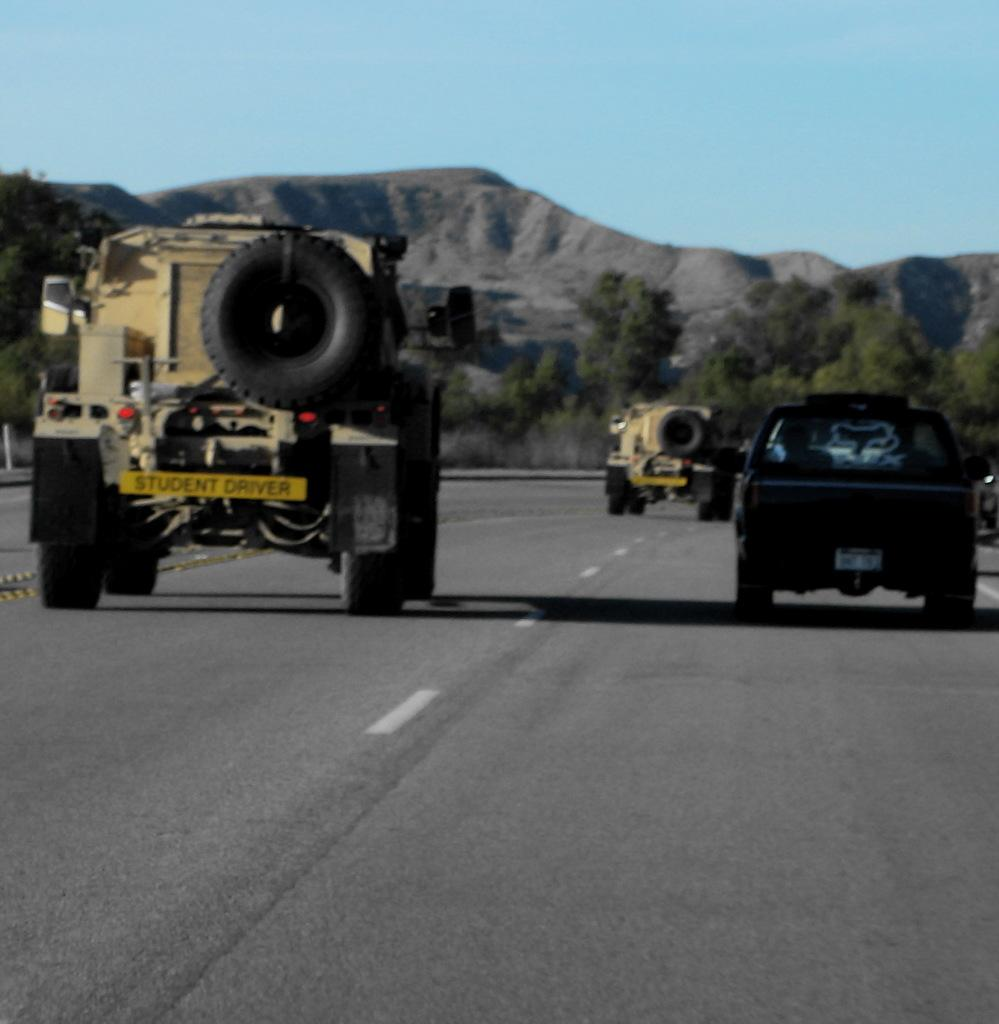What can be seen on the road in the image? There are vehicles on the road in the image. What type of natural scenery is visible in the background of the image? There are trees and mountains in the background of the image. What part of the natural environment is visible in the image? The sky is visible in the background of the image. Can you tell me how many yaks are grazing on the cheese in the image? There are no yaks or cheese present in the image; it features vehicles on the road with trees, mountains, and the sky in the background. 